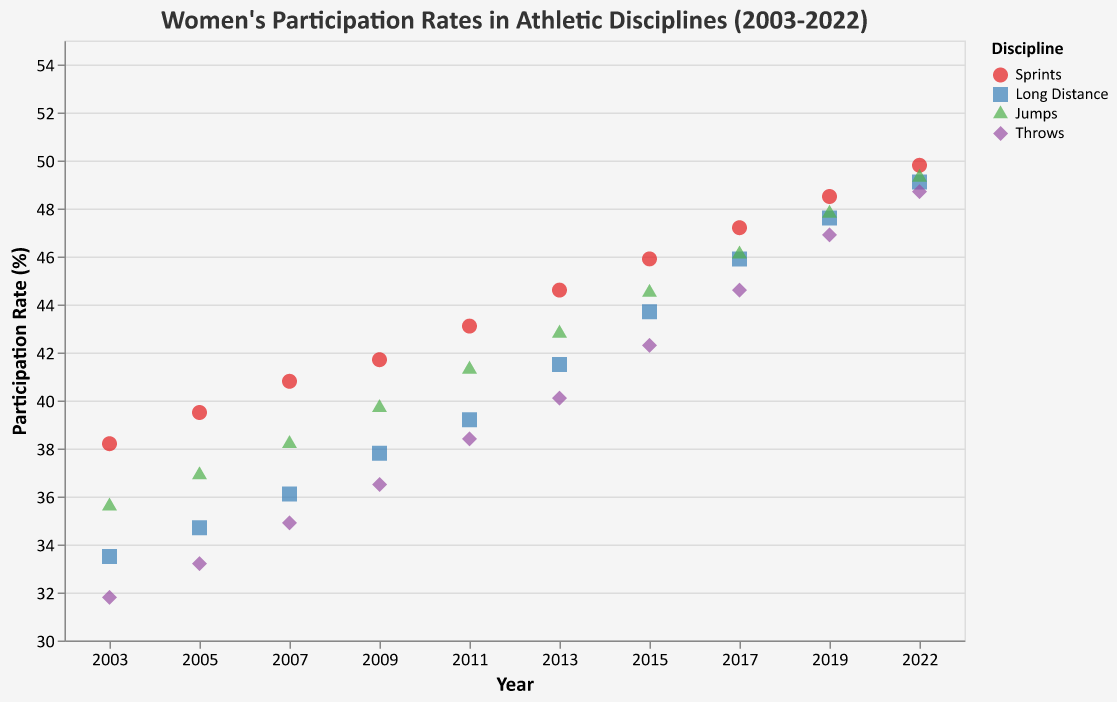What is the title of the plot? The title of the plot is directly written at the top of the plot and in a larger, prominent font, making it easy to identify.
Answer: Women's Participation Rates in Athletic Disciplines (2003-2022) How does the participation rate in Sprints change from 2003 to 2022? The participation rate in Sprints can be observed by finding the values for Sprints in 2003 and 2022 and calculating the difference. In 2003, it is 38.2%, and in 2022, it is 49.8%. The change is 49.8% - 38.2% = 11.6%.
Answer: 11.6% Which discipline had the highest participation rate in 2003? To find this, compare the participation rate for all disciplines in 2003. The rates are 38.2% (Sprints), 33.5% (Long Distance), 35.6% (Jumps), and 31.8% (Throws). The highest rate among these is 38.2% for Sprints.
Answer: Sprints In which year did the participation rate for Long Distance first exceed 40%? Look at the values for Long Distance over the years. The participation rate exceeds 40% for the first time in 2013, with a rate of 41.5%.
Answer: 2013 Which discipline had the least increase in participation rate from 2003 to 2022? Calculate the increase for each discipline from 2003 to 2022:  
- Sprints: 49.8% - 38.2% = 11.6%
- Long Distance: 49.1% - 33.5% = 15.6%
- Jumps: 49.3% - 35.6% = 13.7%
- Throws: 48.7% - 31.8% = 16.9%
The least increase is in Sprints, with an 11.6% increase.
Answer: Sprints What pattern can you observe about the participation rates in Jumps over the two decades? By examining the points for Jumps, it's clear that the participation rate has consistently increased each year from 35.6% in 2003 to 49.3% in 2022, indicating a steady and gradual upward trend.
Answer: Steady and gradual upward trend Compare the participation rates of Sprints and Throws in 2019. Which one is higher? To compare, look at the participation rates for 2019. For Sprints, it is 48.5%. For Throws, it is 46.9%. Sprints has the higher participation rate in 2019.
Answer: Sprints What is the approximate average participation rate for Sprints over the two decades? Calculate the average by summing up the participation rates for Sprints across the years (38.2 + 39.5 + 40.8 + 41.7 + 43.1 + 44.6 + 45.9 + 47.2 + 48.5 + 49.8 = 439.3) and then dividing by the number of years (439.3 / 10).
Answer: 43.9% How many disciplines reached a participation rate of 45% or more by 2022? Check the participation rates for each discipline in 2022: Sprints (49.8%), Long Distance (49.1%), Jumps (49.3%), and Throws (48.7%). All four disciplines have a participation rate of 45% or more.
Answer: Four Which discipline had the most significant participation rate increase between 2005 and 2015? Calculate the increase for each discipline from 2005 to 2015:
- Sprints: 45.9% - 39.5% = 6.4%
- Long Distance: 43.7% - 34.7% = 9.0%
- Jumps: 44.5% - 36.9% = 7.6%
- Throws: 42.3% - 33.2% = 9.1%
Throws had the most significant increase of 9.1% between 2005 and 2015.
Answer: Throws 